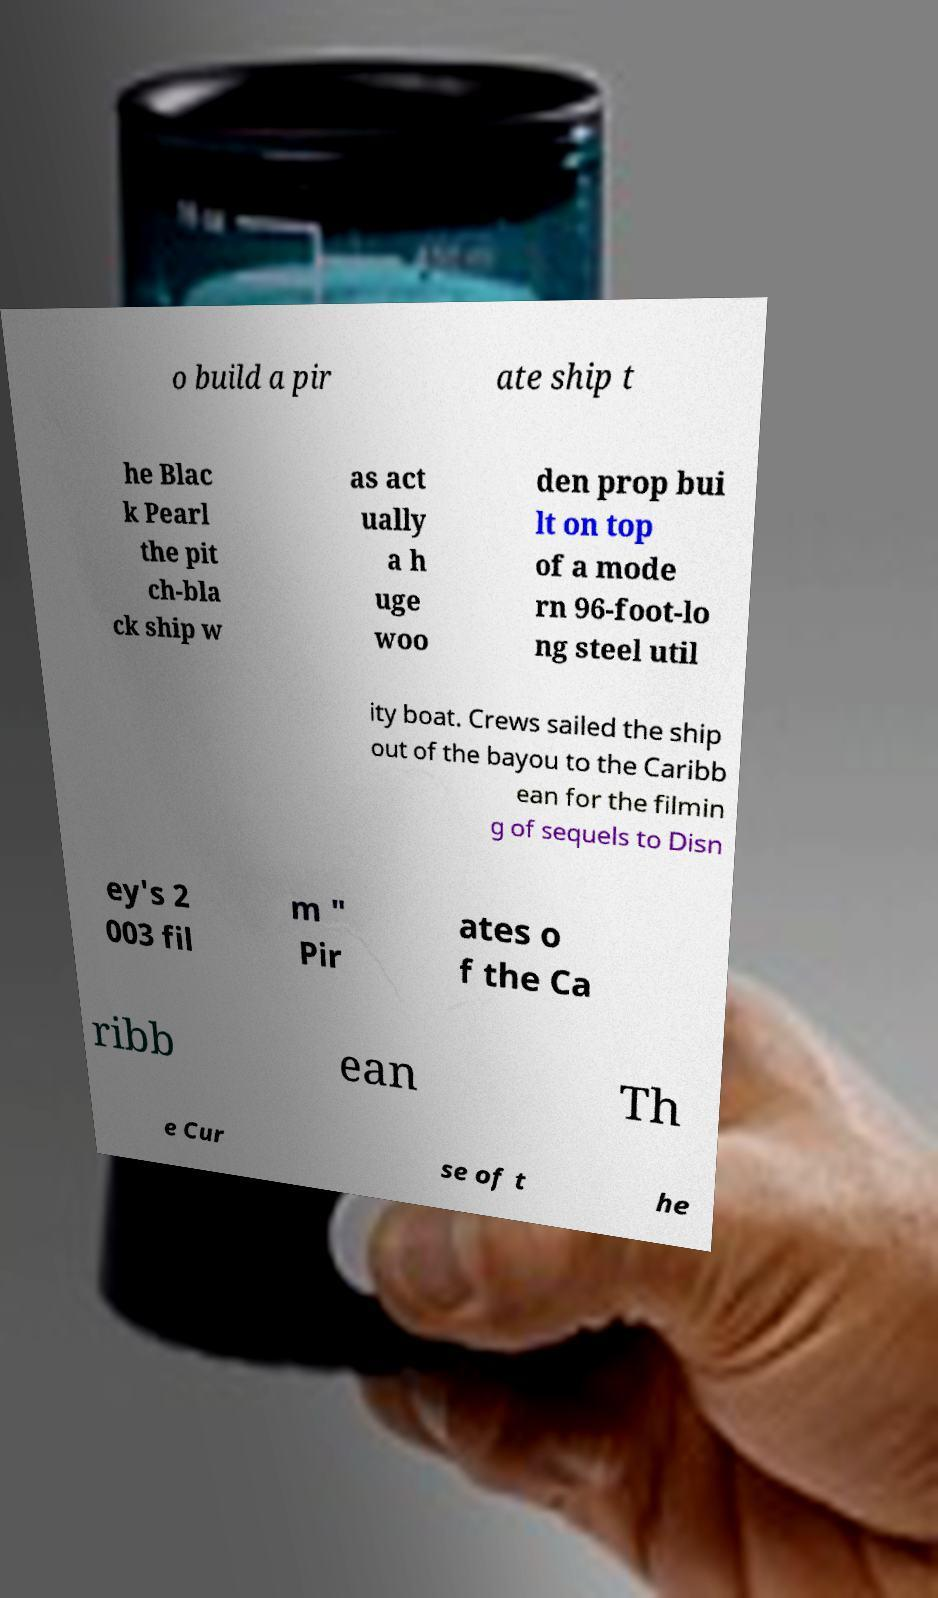I need the written content from this picture converted into text. Can you do that? o build a pir ate ship t he Blac k Pearl the pit ch-bla ck ship w as act ually a h uge woo den prop bui lt on top of a mode rn 96-foot-lo ng steel util ity boat. Crews sailed the ship out of the bayou to the Caribb ean for the filmin g of sequels to Disn ey's 2 003 fil m " Pir ates o f the Ca ribb ean Th e Cur se of t he 